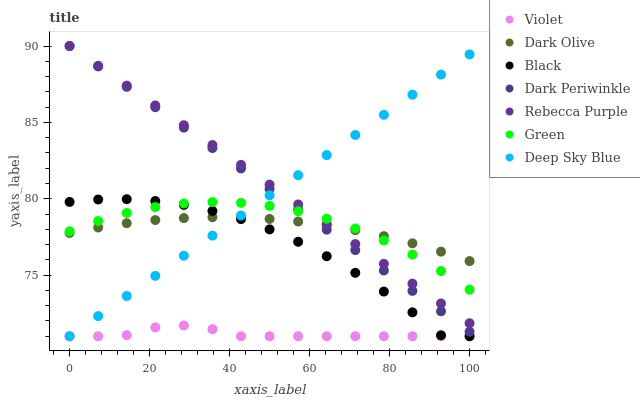Does Violet have the minimum area under the curve?
Answer yes or no. Yes. Does Rebecca Purple have the maximum area under the curve?
Answer yes or no. Yes. Does Green have the minimum area under the curve?
Answer yes or no. No. Does Green have the maximum area under the curve?
Answer yes or no. No. Is Rebecca Purple the smoothest?
Answer yes or no. Yes. Is Black the roughest?
Answer yes or no. Yes. Is Green the smoothest?
Answer yes or no. No. Is Green the roughest?
Answer yes or no. No. Does Deep Sky Blue have the lowest value?
Answer yes or no. Yes. Does Green have the lowest value?
Answer yes or no. No. Does Dark Periwinkle have the highest value?
Answer yes or no. Yes. Does Green have the highest value?
Answer yes or no. No. Is Violet less than Green?
Answer yes or no. Yes. Is Rebecca Purple greater than Black?
Answer yes or no. Yes. Does Deep Sky Blue intersect Dark Periwinkle?
Answer yes or no. Yes. Is Deep Sky Blue less than Dark Periwinkle?
Answer yes or no. No. Is Deep Sky Blue greater than Dark Periwinkle?
Answer yes or no. No. Does Violet intersect Green?
Answer yes or no. No. 